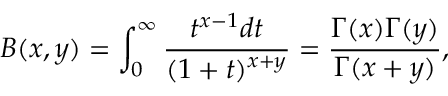Convert formula to latex. <formula><loc_0><loc_0><loc_500><loc_500>B ( x , y ) = \int _ { 0 } ^ { \infty } \frac { t ^ { x - 1 } d t } { ( 1 + t ) ^ { x + y } } = \frac { \Gamma ( x ) \Gamma ( y ) } { \Gamma ( x + y ) } ,</formula> 